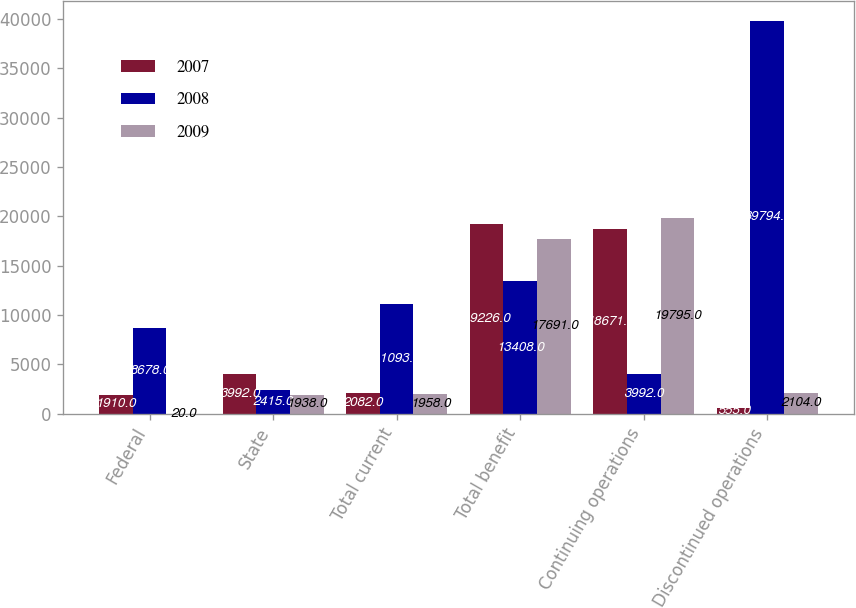<chart> <loc_0><loc_0><loc_500><loc_500><stacked_bar_chart><ecel><fcel>Federal<fcel>State<fcel>Total current<fcel>Total benefit<fcel>Continuing operations<fcel>Discontinued operations<nl><fcel>2007<fcel>1910<fcel>3992<fcel>2082<fcel>19226<fcel>18671<fcel>555<nl><fcel>2008<fcel>8678<fcel>2415<fcel>11093<fcel>13408<fcel>3992<fcel>39794<nl><fcel>2009<fcel>20<fcel>1938<fcel>1958<fcel>17691<fcel>19795<fcel>2104<nl></chart> 